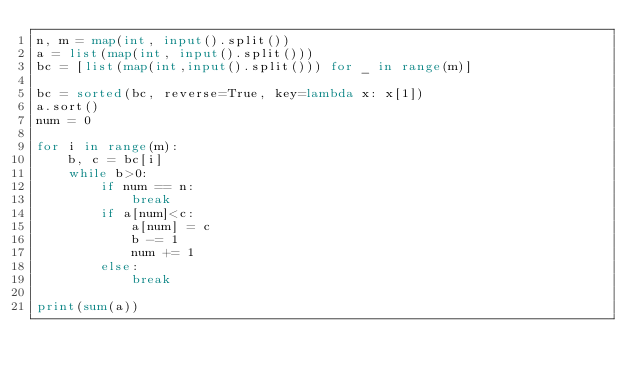<code> <loc_0><loc_0><loc_500><loc_500><_Python_>n, m = map(int, input().split())
a = list(map(int, input().split()))
bc = [list(map(int,input().split())) for _ in range(m)]

bc = sorted(bc, reverse=True, key=lambda x: x[1])
a.sort()
num = 0

for i in range(m):
    b, c = bc[i]
    while b>0:
        if num == n:
            break
        if a[num]<c:
            a[num] = c
            b -= 1
            num += 1
        else:
            break

print(sum(a))</code> 